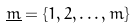Convert formula to latex. <formula><loc_0><loc_0><loc_500><loc_500>\underline { m } = \{ 1 , 2 , \dots , m \}</formula> 